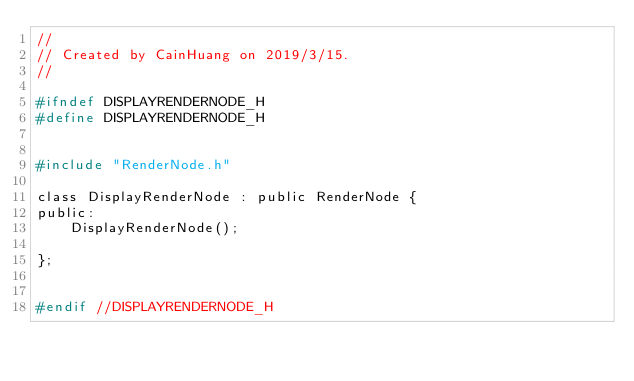Convert code to text. <code><loc_0><loc_0><loc_500><loc_500><_C_>//
// Created by CainHuang on 2019/3/15.
//

#ifndef DISPLAYRENDERNODE_H
#define DISPLAYRENDERNODE_H


#include "RenderNode.h"

class DisplayRenderNode : public RenderNode {
public:
    DisplayRenderNode();

};


#endif //DISPLAYRENDERNODE_H
</code> 